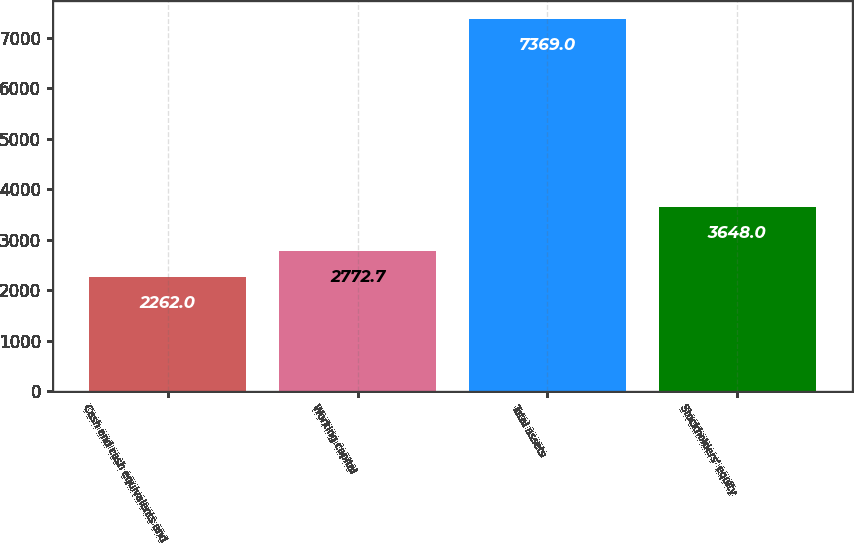Convert chart to OTSL. <chart><loc_0><loc_0><loc_500><loc_500><bar_chart><fcel>Cash and cash equivalents and<fcel>Working capital<fcel>Total assets<fcel>Stockholders' equity<nl><fcel>2262<fcel>2772.7<fcel>7369<fcel>3648<nl></chart> 